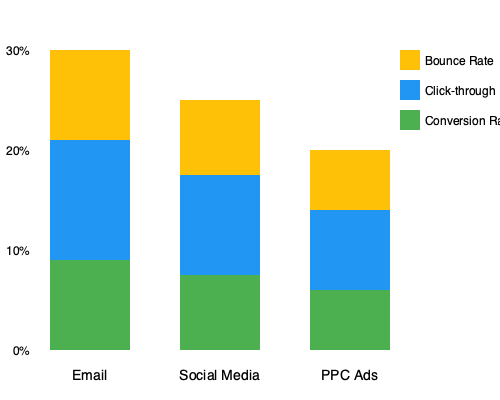As a member of an online community focused on maximizing product potential, you're analyzing the effectiveness of different marketing strategies. Based on the stacked bar chart showing conversion rates, click-through rates, and bounce rates for Email, Social Media, and PPC Ads, which marketing strategy has the highest overall engagement rate (sum of conversion rate and click-through rate)? To determine the marketing strategy with the highest overall engagement rate, we need to sum the conversion rate and click-through rate for each strategy. The bounce rate is not included in this calculation as it represents disengagement.

Let's analyze each strategy:

1. Email:
   - Conversion rate: $\approx 10\%$
   - Click-through rate: $\approx 12\%$
   - Overall engagement rate: $10\% + 12\% = 22\%$

2. Social Media:
   - Conversion rate: $\approx 7.5\%$
   - Click-through rate: $\approx 10\%$
   - Overall engagement rate: $7.5\% + 10\% = 17.5\%$

3. PPC Ads:
   - Conversion rate: $\approx 6\%$
   - Click-through rate: $\approx 8\%$
   - Overall engagement rate: $6\% + 8\% = 14\%$

Comparing the overall engagement rates:
Email: $22\%$
Social Media: $17.5\%$
PPC Ads: $14\%$

The highest overall engagement rate is achieved by the Email marketing strategy at $22\%$.
Answer: Email 